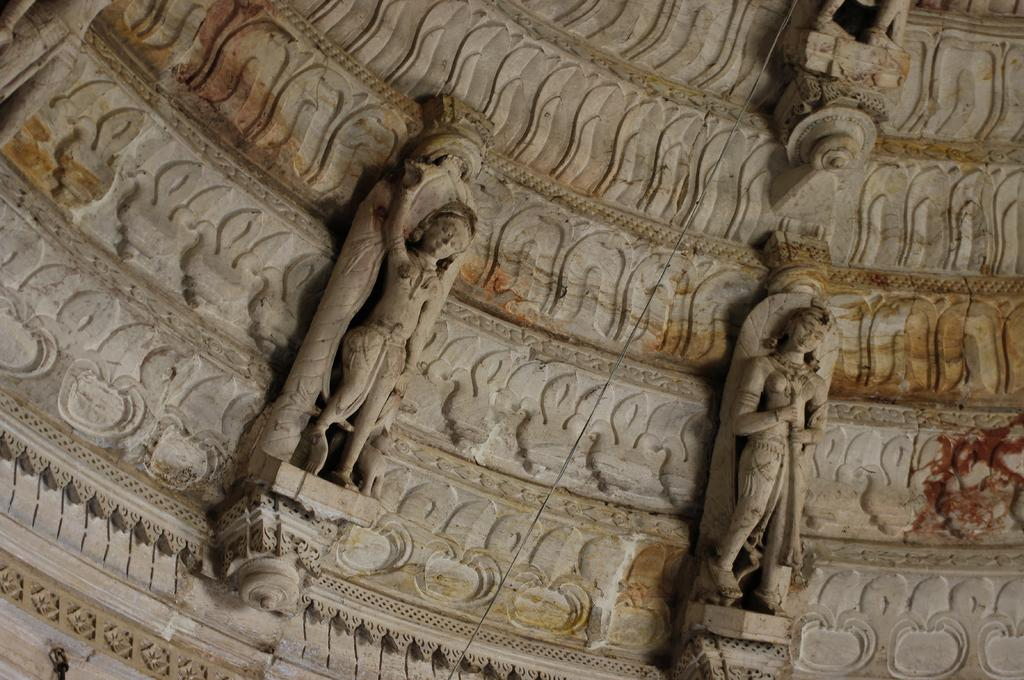What is depicted in the image? There are two sculptures of persons in the image. Where are the sculptures located? The sculptures are on a wall. What attempt was made to smash the sculptures in the image? There is no attempt to smash the sculptures in the image; they are depicted as intact sculptures on a wall. 